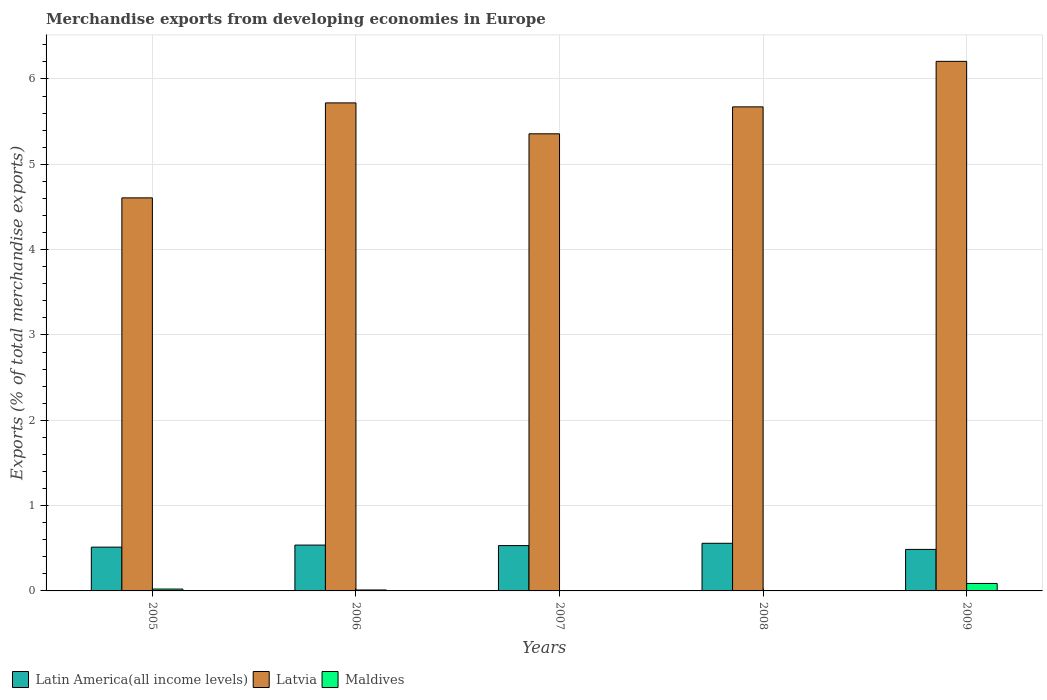How many groups of bars are there?
Your answer should be compact. 5. Are the number of bars per tick equal to the number of legend labels?
Make the answer very short. Yes. How many bars are there on the 3rd tick from the left?
Make the answer very short. 3. How many bars are there on the 1st tick from the right?
Provide a short and direct response. 3. What is the label of the 3rd group of bars from the left?
Keep it short and to the point. 2007. What is the percentage of total merchandise exports in Maldives in 2005?
Ensure brevity in your answer.  0.02. Across all years, what is the maximum percentage of total merchandise exports in Latvia?
Ensure brevity in your answer.  6.21. Across all years, what is the minimum percentage of total merchandise exports in Latin America(all income levels)?
Keep it short and to the point. 0.49. What is the total percentage of total merchandise exports in Latin America(all income levels) in the graph?
Offer a terse response. 2.63. What is the difference between the percentage of total merchandise exports in Maldives in 2006 and that in 2009?
Provide a short and direct response. -0.08. What is the difference between the percentage of total merchandise exports in Latin America(all income levels) in 2009 and the percentage of total merchandise exports in Latvia in 2006?
Keep it short and to the point. -5.23. What is the average percentage of total merchandise exports in Maldives per year?
Your response must be concise. 0.02. In the year 2009, what is the difference between the percentage of total merchandise exports in Latin America(all income levels) and percentage of total merchandise exports in Latvia?
Your answer should be compact. -5.72. What is the ratio of the percentage of total merchandise exports in Latin America(all income levels) in 2005 to that in 2008?
Offer a very short reply. 0.92. What is the difference between the highest and the second highest percentage of total merchandise exports in Latvia?
Provide a succinct answer. 0.49. What is the difference between the highest and the lowest percentage of total merchandise exports in Latvia?
Offer a very short reply. 1.6. What does the 2nd bar from the left in 2009 represents?
Offer a very short reply. Latvia. What does the 2nd bar from the right in 2005 represents?
Your response must be concise. Latvia. Is it the case that in every year, the sum of the percentage of total merchandise exports in Maldives and percentage of total merchandise exports in Latin America(all income levels) is greater than the percentage of total merchandise exports in Latvia?
Ensure brevity in your answer.  No. What is the difference between two consecutive major ticks on the Y-axis?
Your answer should be compact. 1. Are the values on the major ticks of Y-axis written in scientific E-notation?
Offer a very short reply. No. Does the graph contain grids?
Provide a short and direct response. Yes. Where does the legend appear in the graph?
Ensure brevity in your answer.  Bottom left. What is the title of the graph?
Your answer should be very brief. Merchandise exports from developing economies in Europe. Does "Middle East & North Africa (developing only)" appear as one of the legend labels in the graph?
Ensure brevity in your answer.  No. What is the label or title of the X-axis?
Your answer should be very brief. Years. What is the label or title of the Y-axis?
Offer a terse response. Exports (% of total merchandise exports). What is the Exports (% of total merchandise exports) in Latin America(all income levels) in 2005?
Provide a short and direct response. 0.51. What is the Exports (% of total merchandise exports) of Latvia in 2005?
Give a very brief answer. 4.61. What is the Exports (% of total merchandise exports) of Maldives in 2005?
Ensure brevity in your answer.  0.02. What is the Exports (% of total merchandise exports) of Latin America(all income levels) in 2006?
Ensure brevity in your answer.  0.54. What is the Exports (% of total merchandise exports) in Latvia in 2006?
Ensure brevity in your answer.  5.72. What is the Exports (% of total merchandise exports) in Maldives in 2006?
Offer a very short reply. 0.01. What is the Exports (% of total merchandise exports) of Latin America(all income levels) in 2007?
Provide a short and direct response. 0.53. What is the Exports (% of total merchandise exports) of Latvia in 2007?
Ensure brevity in your answer.  5.36. What is the Exports (% of total merchandise exports) in Maldives in 2007?
Give a very brief answer. 0. What is the Exports (% of total merchandise exports) of Latin America(all income levels) in 2008?
Provide a short and direct response. 0.56. What is the Exports (% of total merchandise exports) in Latvia in 2008?
Give a very brief answer. 5.67. What is the Exports (% of total merchandise exports) of Maldives in 2008?
Your response must be concise. 0. What is the Exports (% of total merchandise exports) of Latin America(all income levels) in 2009?
Your response must be concise. 0.49. What is the Exports (% of total merchandise exports) of Latvia in 2009?
Provide a succinct answer. 6.21. What is the Exports (% of total merchandise exports) in Maldives in 2009?
Provide a short and direct response. 0.09. Across all years, what is the maximum Exports (% of total merchandise exports) of Latin America(all income levels)?
Provide a succinct answer. 0.56. Across all years, what is the maximum Exports (% of total merchandise exports) of Latvia?
Your response must be concise. 6.21. Across all years, what is the maximum Exports (% of total merchandise exports) of Maldives?
Give a very brief answer. 0.09. Across all years, what is the minimum Exports (% of total merchandise exports) in Latin America(all income levels)?
Your answer should be very brief. 0.49. Across all years, what is the minimum Exports (% of total merchandise exports) of Latvia?
Keep it short and to the point. 4.61. Across all years, what is the minimum Exports (% of total merchandise exports) of Maldives?
Your answer should be compact. 0. What is the total Exports (% of total merchandise exports) in Latin America(all income levels) in the graph?
Make the answer very short. 2.63. What is the total Exports (% of total merchandise exports) in Latvia in the graph?
Make the answer very short. 27.56. What is the total Exports (% of total merchandise exports) of Maldives in the graph?
Provide a short and direct response. 0.12. What is the difference between the Exports (% of total merchandise exports) in Latin America(all income levels) in 2005 and that in 2006?
Your answer should be very brief. -0.02. What is the difference between the Exports (% of total merchandise exports) in Latvia in 2005 and that in 2006?
Offer a terse response. -1.11. What is the difference between the Exports (% of total merchandise exports) in Maldives in 2005 and that in 2006?
Your answer should be compact. 0.01. What is the difference between the Exports (% of total merchandise exports) in Latin America(all income levels) in 2005 and that in 2007?
Ensure brevity in your answer.  -0.02. What is the difference between the Exports (% of total merchandise exports) of Latvia in 2005 and that in 2007?
Ensure brevity in your answer.  -0.75. What is the difference between the Exports (% of total merchandise exports) of Maldives in 2005 and that in 2007?
Ensure brevity in your answer.  0.02. What is the difference between the Exports (% of total merchandise exports) of Latin America(all income levels) in 2005 and that in 2008?
Your response must be concise. -0.04. What is the difference between the Exports (% of total merchandise exports) in Latvia in 2005 and that in 2008?
Offer a terse response. -1.07. What is the difference between the Exports (% of total merchandise exports) of Maldives in 2005 and that in 2008?
Offer a very short reply. 0.02. What is the difference between the Exports (% of total merchandise exports) of Latin America(all income levels) in 2005 and that in 2009?
Your answer should be compact. 0.03. What is the difference between the Exports (% of total merchandise exports) of Maldives in 2005 and that in 2009?
Offer a very short reply. -0.07. What is the difference between the Exports (% of total merchandise exports) of Latin America(all income levels) in 2006 and that in 2007?
Provide a short and direct response. 0.01. What is the difference between the Exports (% of total merchandise exports) of Latvia in 2006 and that in 2007?
Your response must be concise. 0.36. What is the difference between the Exports (% of total merchandise exports) in Maldives in 2006 and that in 2007?
Keep it short and to the point. 0.01. What is the difference between the Exports (% of total merchandise exports) of Latin America(all income levels) in 2006 and that in 2008?
Offer a terse response. -0.02. What is the difference between the Exports (% of total merchandise exports) of Latvia in 2006 and that in 2008?
Provide a succinct answer. 0.05. What is the difference between the Exports (% of total merchandise exports) of Maldives in 2006 and that in 2008?
Offer a terse response. 0.01. What is the difference between the Exports (% of total merchandise exports) in Latin America(all income levels) in 2006 and that in 2009?
Keep it short and to the point. 0.05. What is the difference between the Exports (% of total merchandise exports) in Latvia in 2006 and that in 2009?
Your response must be concise. -0.49. What is the difference between the Exports (% of total merchandise exports) in Maldives in 2006 and that in 2009?
Give a very brief answer. -0.08. What is the difference between the Exports (% of total merchandise exports) in Latin America(all income levels) in 2007 and that in 2008?
Offer a very short reply. -0.03. What is the difference between the Exports (% of total merchandise exports) of Latvia in 2007 and that in 2008?
Your answer should be very brief. -0.32. What is the difference between the Exports (% of total merchandise exports) in Maldives in 2007 and that in 2008?
Offer a very short reply. 0. What is the difference between the Exports (% of total merchandise exports) in Latin America(all income levels) in 2007 and that in 2009?
Your answer should be very brief. 0.04. What is the difference between the Exports (% of total merchandise exports) in Latvia in 2007 and that in 2009?
Give a very brief answer. -0.85. What is the difference between the Exports (% of total merchandise exports) of Maldives in 2007 and that in 2009?
Make the answer very short. -0.09. What is the difference between the Exports (% of total merchandise exports) of Latin America(all income levels) in 2008 and that in 2009?
Provide a succinct answer. 0.07. What is the difference between the Exports (% of total merchandise exports) of Latvia in 2008 and that in 2009?
Offer a terse response. -0.53. What is the difference between the Exports (% of total merchandise exports) in Maldives in 2008 and that in 2009?
Offer a very short reply. -0.09. What is the difference between the Exports (% of total merchandise exports) of Latin America(all income levels) in 2005 and the Exports (% of total merchandise exports) of Latvia in 2006?
Your answer should be very brief. -5.21. What is the difference between the Exports (% of total merchandise exports) of Latin America(all income levels) in 2005 and the Exports (% of total merchandise exports) of Maldives in 2006?
Provide a short and direct response. 0.5. What is the difference between the Exports (% of total merchandise exports) in Latvia in 2005 and the Exports (% of total merchandise exports) in Maldives in 2006?
Your answer should be very brief. 4.6. What is the difference between the Exports (% of total merchandise exports) of Latin America(all income levels) in 2005 and the Exports (% of total merchandise exports) of Latvia in 2007?
Give a very brief answer. -4.84. What is the difference between the Exports (% of total merchandise exports) in Latin America(all income levels) in 2005 and the Exports (% of total merchandise exports) in Maldives in 2007?
Keep it short and to the point. 0.51. What is the difference between the Exports (% of total merchandise exports) of Latvia in 2005 and the Exports (% of total merchandise exports) of Maldives in 2007?
Keep it short and to the point. 4.6. What is the difference between the Exports (% of total merchandise exports) of Latin America(all income levels) in 2005 and the Exports (% of total merchandise exports) of Latvia in 2008?
Provide a succinct answer. -5.16. What is the difference between the Exports (% of total merchandise exports) in Latin America(all income levels) in 2005 and the Exports (% of total merchandise exports) in Maldives in 2008?
Give a very brief answer. 0.51. What is the difference between the Exports (% of total merchandise exports) of Latvia in 2005 and the Exports (% of total merchandise exports) of Maldives in 2008?
Provide a succinct answer. 4.61. What is the difference between the Exports (% of total merchandise exports) of Latin America(all income levels) in 2005 and the Exports (% of total merchandise exports) of Latvia in 2009?
Provide a succinct answer. -5.69. What is the difference between the Exports (% of total merchandise exports) in Latin America(all income levels) in 2005 and the Exports (% of total merchandise exports) in Maldives in 2009?
Your answer should be compact. 0.43. What is the difference between the Exports (% of total merchandise exports) of Latvia in 2005 and the Exports (% of total merchandise exports) of Maldives in 2009?
Your answer should be very brief. 4.52. What is the difference between the Exports (% of total merchandise exports) in Latin America(all income levels) in 2006 and the Exports (% of total merchandise exports) in Latvia in 2007?
Offer a terse response. -4.82. What is the difference between the Exports (% of total merchandise exports) of Latin America(all income levels) in 2006 and the Exports (% of total merchandise exports) of Maldives in 2007?
Your response must be concise. 0.54. What is the difference between the Exports (% of total merchandise exports) of Latvia in 2006 and the Exports (% of total merchandise exports) of Maldives in 2007?
Your response must be concise. 5.72. What is the difference between the Exports (% of total merchandise exports) of Latin America(all income levels) in 2006 and the Exports (% of total merchandise exports) of Latvia in 2008?
Your answer should be very brief. -5.14. What is the difference between the Exports (% of total merchandise exports) in Latin America(all income levels) in 2006 and the Exports (% of total merchandise exports) in Maldives in 2008?
Your response must be concise. 0.54. What is the difference between the Exports (% of total merchandise exports) of Latvia in 2006 and the Exports (% of total merchandise exports) of Maldives in 2008?
Your answer should be compact. 5.72. What is the difference between the Exports (% of total merchandise exports) of Latin America(all income levels) in 2006 and the Exports (% of total merchandise exports) of Latvia in 2009?
Provide a short and direct response. -5.67. What is the difference between the Exports (% of total merchandise exports) of Latin America(all income levels) in 2006 and the Exports (% of total merchandise exports) of Maldives in 2009?
Your answer should be compact. 0.45. What is the difference between the Exports (% of total merchandise exports) in Latvia in 2006 and the Exports (% of total merchandise exports) in Maldives in 2009?
Your response must be concise. 5.63. What is the difference between the Exports (% of total merchandise exports) in Latin America(all income levels) in 2007 and the Exports (% of total merchandise exports) in Latvia in 2008?
Your answer should be very brief. -5.14. What is the difference between the Exports (% of total merchandise exports) of Latin America(all income levels) in 2007 and the Exports (% of total merchandise exports) of Maldives in 2008?
Offer a terse response. 0.53. What is the difference between the Exports (% of total merchandise exports) in Latvia in 2007 and the Exports (% of total merchandise exports) in Maldives in 2008?
Your answer should be very brief. 5.36. What is the difference between the Exports (% of total merchandise exports) in Latin America(all income levels) in 2007 and the Exports (% of total merchandise exports) in Latvia in 2009?
Make the answer very short. -5.68. What is the difference between the Exports (% of total merchandise exports) in Latin America(all income levels) in 2007 and the Exports (% of total merchandise exports) in Maldives in 2009?
Make the answer very short. 0.44. What is the difference between the Exports (% of total merchandise exports) of Latvia in 2007 and the Exports (% of total merchandise exports) of Maldives in 2009?
Your response must be concise. 5.27. What is the difference between the Exports (% of total merchandise exports) in Latin America(all income levels) in 2008 and the Exports (% of total merchandise exports) in Latvia in 2009?
Your answer should be compact. -5.65. What is the difference between the Exports (% of total merchandise exports) in Latin America(all income levels) in 2008 and the Exports (% of total merchandise exports) in Maldives in 2009?
Offer a terse response. 0.47. What is the difference between the Exports (% of total merchandise exports) in Latvia in 2008 and the Exports (% of total merchandise exports) in Maldives in 2009?
Your answer should be compact. 5.59. What is the average Exports (% of total merchandise exports) of Latin America(all income levels) per year?
Offer a very short reply. 0.53. What is the average Exports (% of total merchandise exports) of Latvia per year?
Offer a terse response. 5.51. What is the average Exports (% of total merchandise exports) in Maldives per year?
Provide a succinct answer. 0.02. In the year 2005, what is the difference between the Exports (% of total merchandise exports) of Latin America(all income levels) and Exports (% of total merchandise exports) of Latvia?
Give a very brief answer. -4.09. In the year 2005, what is the difference between the Exports (% of total merchandise exports) of Latin America(all income levels) and Exports (% of total merchandise exports) of Maldives?
Offer a very short reply. 0.49. In the year 2005, what is the difference between the Exports (% of total merchandise exports) in Latvia and Exports (% of total merchandise exports) in Maldives?
Keep it short and to the point. 4.59. In the year 2006, what is the difference between the Exports (% of total merchandise exports) in Latin America(all income levels) and Exports (% of total merchandise exports) in Latvia?
Provide a short and direct response. -5.18. In the year 2006, what is the difference between the Exports (% of total merchandise exports) of Latin America(all income levels) and Exports (% of total merchandise exports) of Maldives?
Offer a terse response. 0.53. In the year 2006, what is the difference between the Exports (% of total merchandise exports) in Latvia and Exports (% of total merchandise exports) in Maldives?
Keep it short and to the point. 5.71. In the year 2007, what is the difference between the Exports (% of total merchandise exports) of Latin America(all income levels) and Exports (% of total merchandise exports) of Latvia?
Provide a succinct answer. -4.83. In the year 2007, what is the difference between the Exports (% of total merchandise exports) in Latin America(all income levels) and Exports (% of total merchandise exports) in Maldives?
Your answer should be compact. 0.53. In the year 2007, what is the difference between the Exports (% of total merchandise exports) in Latvia and Exports (% of total merchandise exports) in Maldives?
Your answer should be compact. 5.36. In the year 2008, what is the difference between the Exports (% of total merchandise exports) of Latin America(all income levels) and Exports (% of total merchandise exports) of Latvia?
Keep it short and to the point. -5.12. In the year 2008, what is the difference between the Exports (% of total merchandise exports) in Latin America(all income levels) and Exports (% of total merchandise exports) in Maldives?
Your response must be concise. 0.56. In the year 2008, what is the difference between the Exports (% of total merchandise exports) in Latvia and Exports (% of total merchandise exports) in Maldives?
Ensure brevity in your answer.  5.67. In the year 2009, what is the difference between the Exports (% of total merchandise exports) of Latin America(all income levels) and Exports (% of total merchandise exports) of Latvia?
Make the answer very short. -5.72. In the year 2009, what is the difference between the Exports (% of total merchandise exports) of Latin America(all income levels) and Exports (% of total merchandise exports) of Maldives?
Your answer should be compact. 0.4. In the year 2009, what is the difference between the Exports (% of total merchandise exports) of Latvia and Exports (% of total merchandise exports) of Maldives?
Offer a terse response. 6.12. What is the ratio of the Exports (% of total merchandise exports) in Latin America(all income levels) in 2005 to that in 2006?
Provide a succinct answer. 0.96. What is the ratio of the Exports (% of total merchandise exports) in Latvia in 2005 to that in 2006?
Your answer should be very brief. 0.81. What is the ratio of the Exports (% of total merchandise exports) in Maldives in 2005 to that in 2006?
Provide a succinct answer. 1.97. What is the ratio of the Exports (% of total merchandise exports) of Latin America(all income levels) in 2005 to that in 2007?
Keep it short and to the point. 0.97. What is the ratio of the Exports (% of total merchandise exports) in Latvia in 2005 to that in 2007?
Your response must be concise. 0.86. What is the ratio of the Exports (% of total merchandise exports) in Maldives in 2005 to that in 2007?
Your response must be concise. 11.04. What is the ratio of the Exports (% of total merchandise exports) in Latin America(all income levels) in 2005 to that in 2008?
Provide a succinct answer. 0.92. What is the ratio of the Exports (% of total merchandise exports) in Latvia in 2005 to that in 2008?
Ensure brevity in your answer.  0.81. What is the ratio of the Exports (% of total merchandise exports) of Maldives in 2005 to that in 2008?
Keep it short and to the point. 69.69. What is the ratio of the Exports (% of total merchandise exports) of Latin America(all income levels) in 2005 to that in 2009?
Make the answer very short. 1.06. What is the ratio of the Exports (% of total merchandise exports) in Latvia in 2005 to that in 2009?
Give a very brief answer. 0.74. What is the ratio of the Exports (% of total merchandise exports) in Maldives in 2005 to that in 2009?
Your answer should be very brief. 0.25. What is the ratio of the Exports (% of total merchandise exports) in Latin America(all income levels) in 2006 to that in 2007?
Offer a very short reply. 1.01. What is the ratio of the Exports (% of total merchandise exports) in Latvia in 2006 to that in 2007?
Your answer should be compact. 1.07. What is the ratio of the Exports (% of total merchandise exports) in Maldives in 2006 to that in 2007?
Provide a succinct answer. 5.62. What is the ratio of the Exports (% of total merchandise exports) of Latin America(all income levels) in 2006 to that in 2008?
Give a very brief answer. 0.96. What is the ratio of the Exports (% of total merchandise exports) in Latvia in 2006 to that in 2008?
Provide a short and direct response. 1.01. What is the ratio of the Exports (% of total merchandise exports) of Maldives in 2006 to that in 2008?
Ensure brevity in your answer.  35.46. What is the ratio of the Exports (% of total merchandise exports) of Latin America(all income levels) in 2006 to that in 2009?
Provide a short and direct response. 1.1. What is the ratio of the Exports (% of total merchandise exports) in Latvia in 2006 to that in 2009?
Provide a short and direct response. 0.92. What is the ratio of the Exports (% of total merchandise exports) in Maldives in 2006 to that in 2009?
Provide a short and direct response. 0.13. What is the ratio of the Exports (% of total merchandise exports) of Latin America(all income levels) in 2007 to that in 2008?
Ensure brevity in your answer.  0.95. What is the ratio of the Exports (% of total merchandise exports) of Maldives in 2007 to that in 2008?
Your answer should be compact. 6.31. What is the ratio of the Exports (% of total merchandise exports) of Latin America(all income levels) in 2007 to that in 2009?
Your answer should be compact. 1.09. What is the ratio of the Exports (% of total merchandise exports) in Latvia in 2007 to that in 2009?
Provide a succinct answer. 0.86. What is the ratio of the Exports (% of total merchandise exports) in Maldives in 2007 to that in 2009?
Provide a succinct answer. 0.02. What is the ratio of the Exports (% of total merchandise exports) in Latin America(all income levels) in 2008 to that in 2009?
Provide a succinct answer. 1.15. What is the ratio of the Exports (% of total merchandise exports) in Latvia in 2008 to that in 2009?
Offer a very short reply. 0.91. What is the ratio of the Exports (% of total merchandise exports) in Maldives in 2008 to that in 2009?
Your response must be concise. 0. What is the difference between the highest and the second highest Exports (% of total merchandise exports) of Latin America(all income levels)?
Your answer should be compact. 0.02. What is the difference between the highest and the second highest Exports (% of total merchandise exports) of Latvia?
Provide a succinct answer. 0.49. What is the difference between the highest and the second highest Exports (% of total merchandise exports) of Maldives?
Provide a succinct answer. 0.07. What is the difference between the highest and the lowest Exports (% of total merchandise exports) of Latin America(all income levels)?
Your answer should be compact. 0.07. What is the difference between the highest and the lowest Exports (% of total merchandise exports) of Maldives?
Provide a succinct answer. 0.09. 